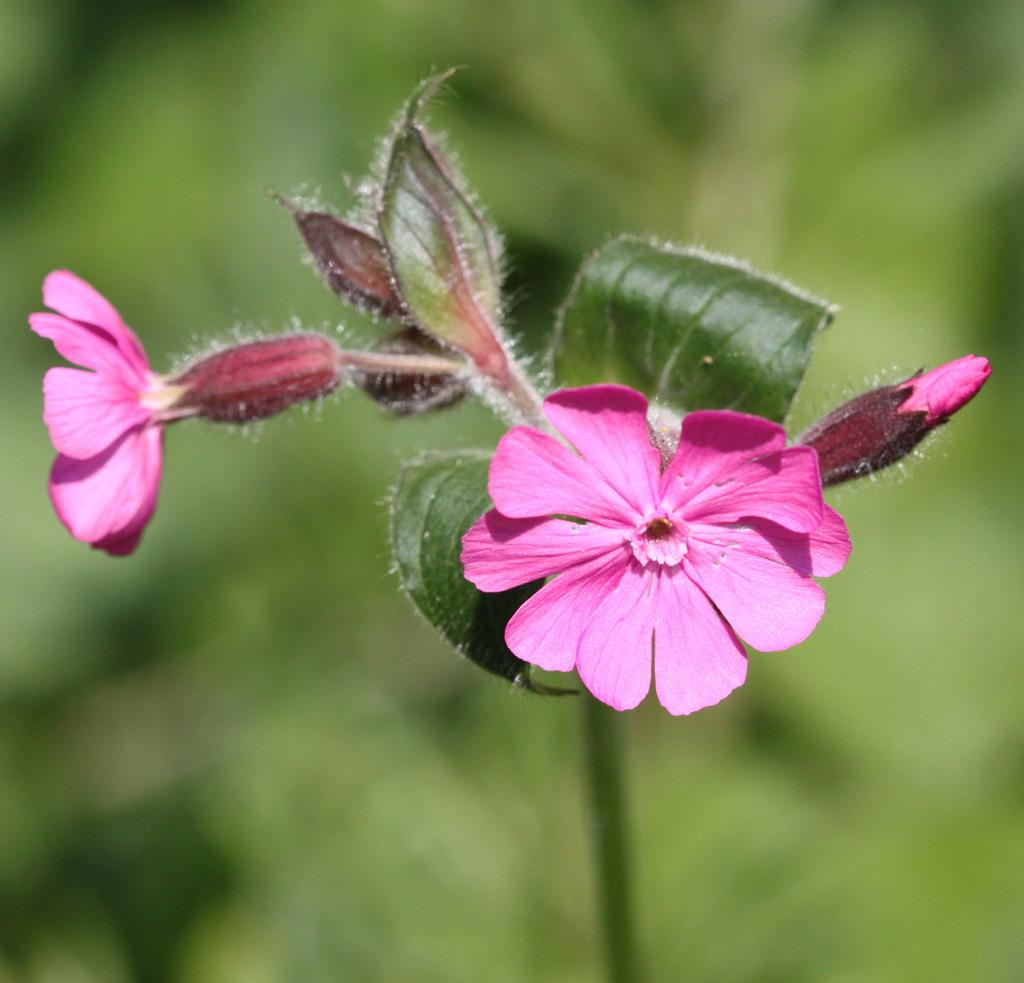What type of plants are in the image? There are flowers in the image. What color are the flowers? The flowers are pink. What other part of the plants can be seen in the image? There are green leaves in the image. How would you describe the background of the image? The background of the image is blurred. What type of cat can be seen walking on the sidewalk in the image? There is no cat or sidewalk present in the image; it features pink flowers and green leaves with a blurred background. 